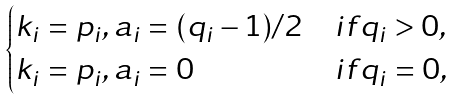<formula> <loc_0><loc_0><loc_500><loc_500>\begin{cases} k _ { i } = p _ { i } , a _ { i } = ( q _ { i } - 1 ) / 2 & i f q _ { i } > 0 , \\ k _ { i } = p _ { i } , a _ { i } = 0 & i f q _ { i } = 0 , \end{cases}</formula> 